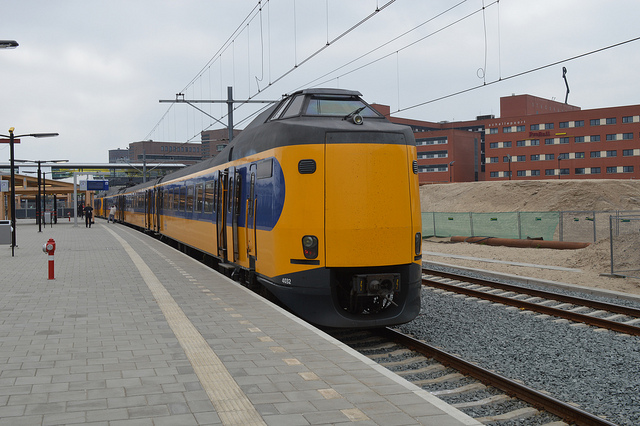<image>What track is the red train at? There is no red train in the image. However, if there was one, it could be on the left, right, or another track further down. What track is the red train at? There is no red train on the track. 